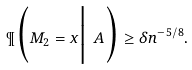Convert formula to latex. <formula><loc_0><loc_0><loc_500><loc_500>\P \Big ( M _ { 2 } = x \Big | \ A \Big ) \geq \delta n ^ { - 5 / 8 } .</formula> 